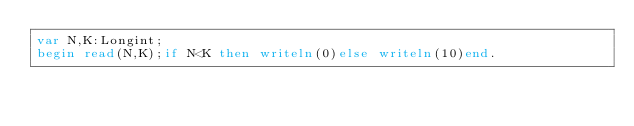Convert code to text. <code><loc_0><loc_0><loc_500><loc_500><_Pascal_>var N,K:Longint;
begin read(N,K);if N<K then writeln(0)else writeln(10)end.</code> 